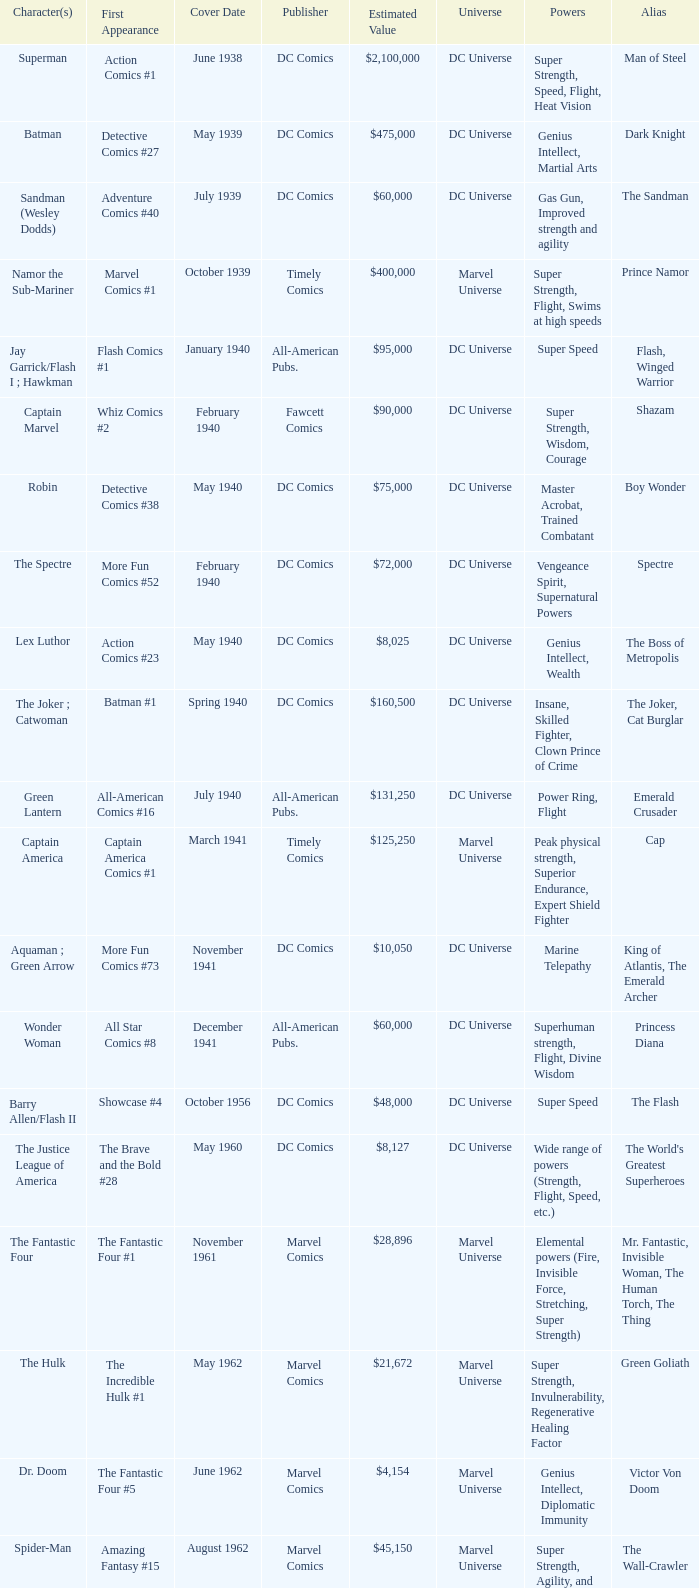Who publishes Wolverine? Marvel Comics. 